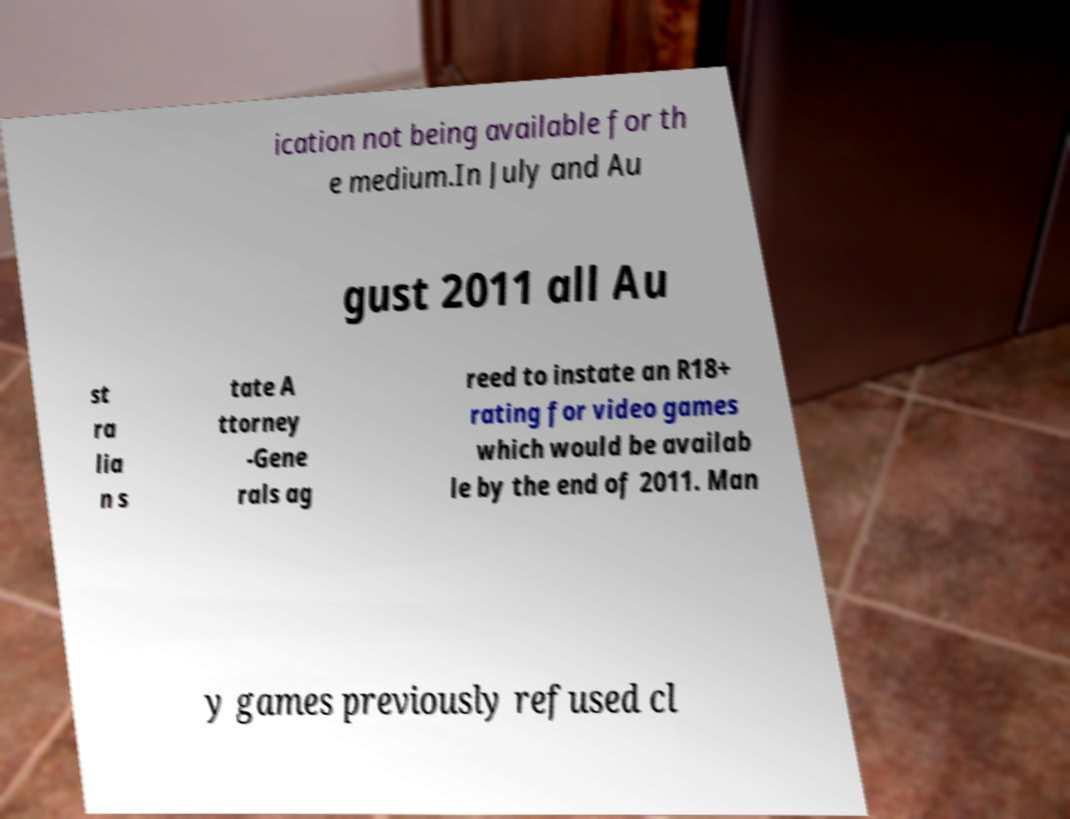Could you assist in decoding the text presented in this image and type it out clearly? ication not being available for th e medium.In July and Au gust 2011 all Au st ra lia n s tate A ttorney -Gene rals ag reed to instate an R18+ rating for video games which would be availab le by the end of 2011. Man y games previously refused cl 